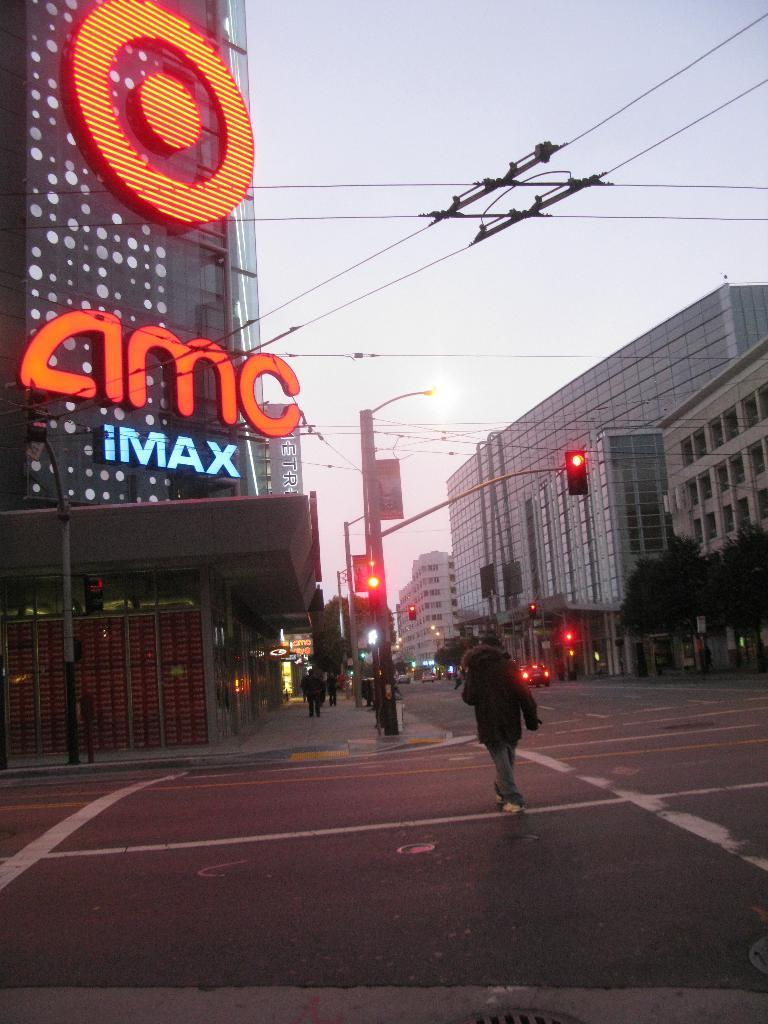<image>
Describe the image concisely. an amc theater and an imax one as well 